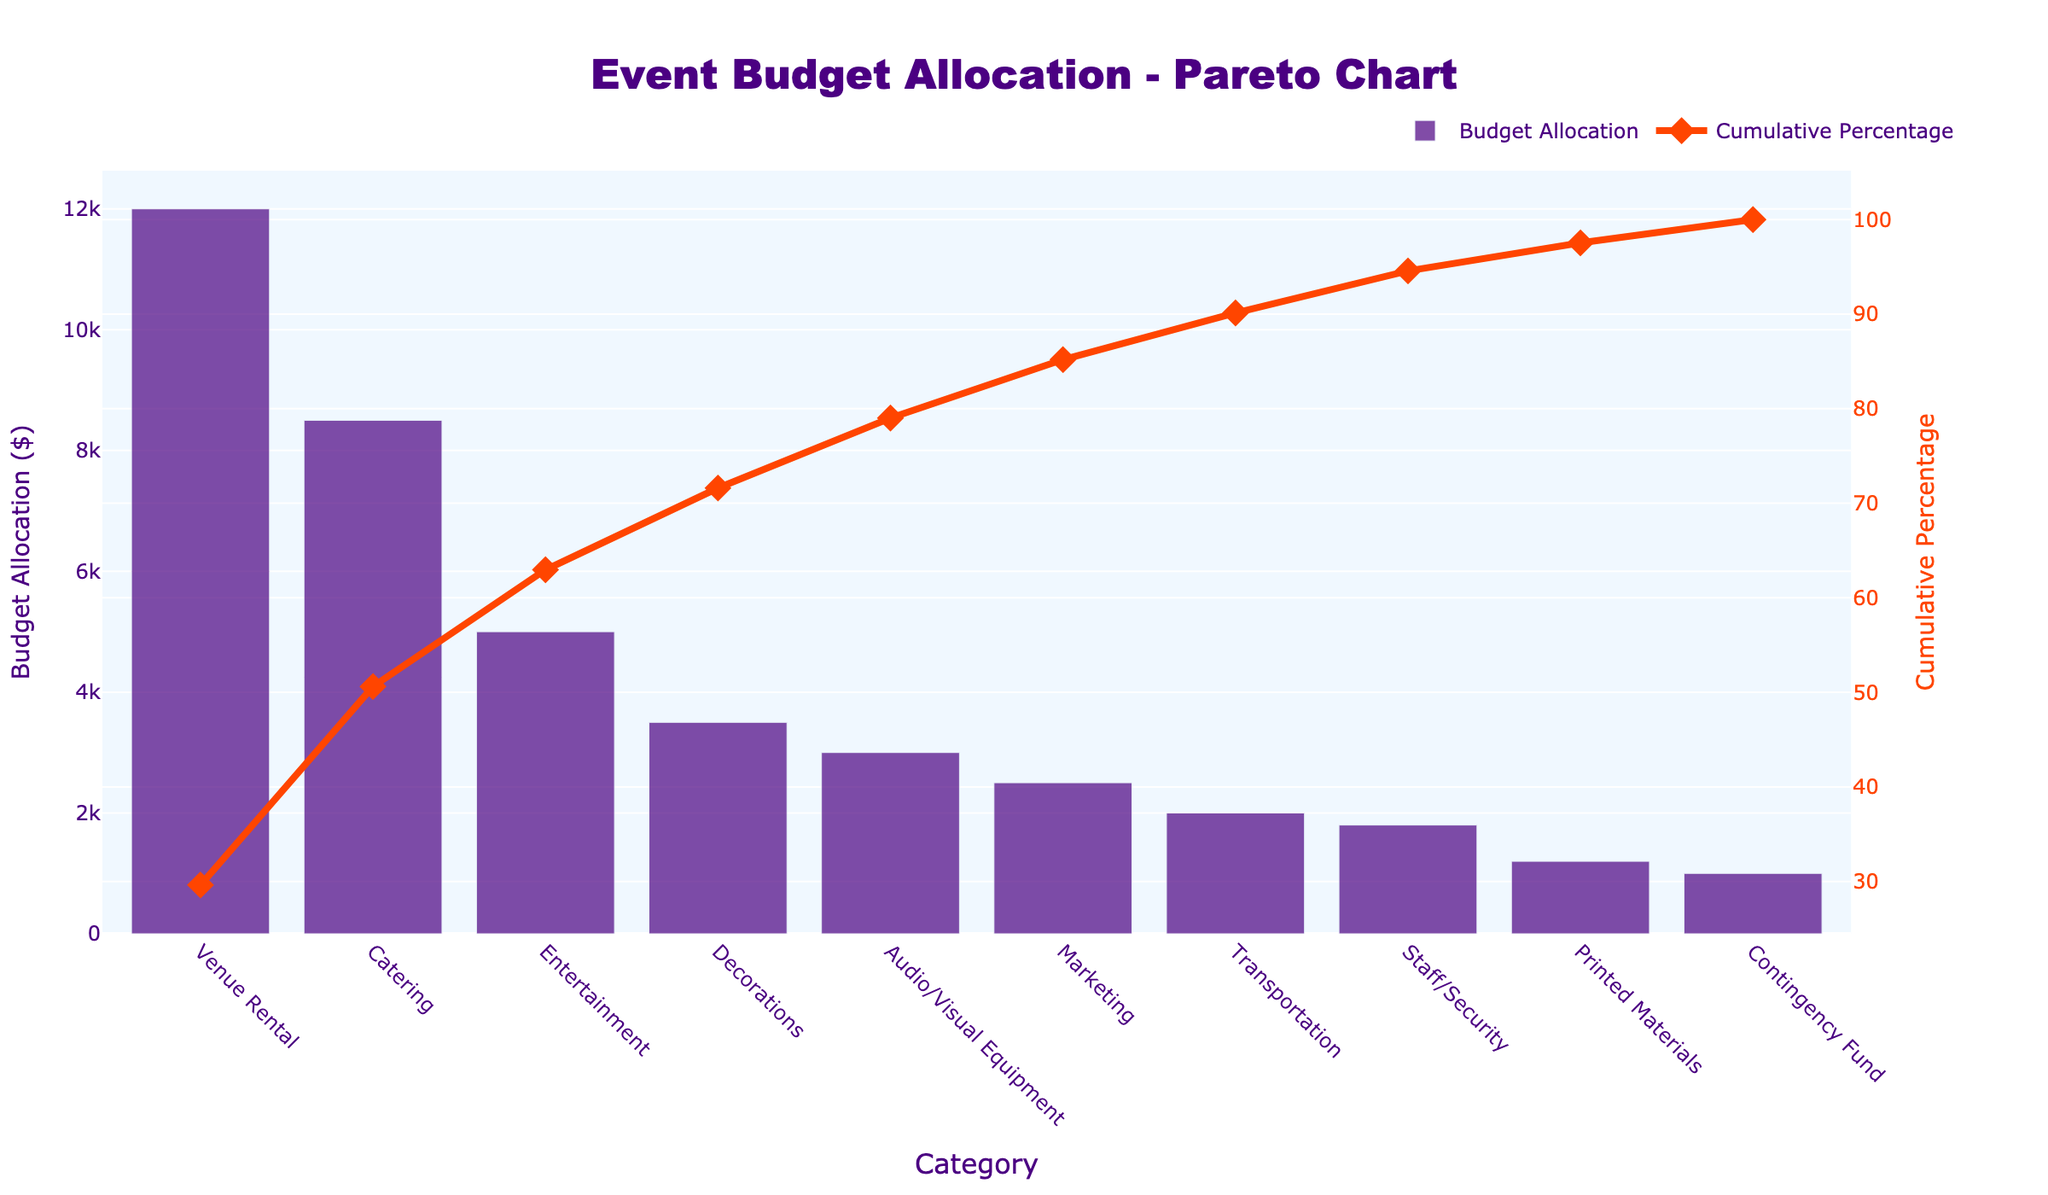What is the title of the Pareto chart? The title of the chart is prominently displayed at the top and reads "Event Budget Allocation - Pareto Chart".
Answer: Event Budget Allocation - Pareto Chart What category has the highest budget allocation? The first bar on the x-axis is the tallest, indicating the "Venue Rental" category.
Answer: Venue Rental How much money is allocated to the "Catering" category? The height of the second bar on the chart represents the "Catering" category, which is labeled as $8,500.
Answer: $8,500 What percentage of the total budget is accounted for by the "Venue Rental" and "Catering" categories together? Summing the budget for "Venue Rental" ($12,000) and "Catering" ($8,500) gives $20,500. The cumulative percentage line for the "Catering" category is just above 55%, indicating these two categories combined account for around 57%.
Answer: 57% Which category contributes to reaching the 80% cumulative budget allocation? The cumulative percentage line crosses the 80% mark between "Audio/Visual Equipment" and "Marketing". So, "Audio/Visual Equipment" is the last category contributing to the 80% cumulative total.
Answer: Audio/Visual Equipment What is the cumulative percentage after the "Entertainment" category? The line graph corresponding to the cumulative percentage shows a value of approximately 72% at the "Entertainment" category.
Answer: 72% Does the "Contingency Fund" have a higher budget allocation than "Printed Materials"? The bar representing the "Contingency Fund" is shorter than the "Printed Materials" bar, indicating a lower budget allocation for the former.
Answer: No Between "Staff/Security" and "Transportation," which has a higher budget allocation? The bar representing "Transportation" is taller than the "Staff/Security" bar, indicating a higher budget allocation for "Transportation".
Answer: Transportation What are the colors used for the bar and line charts in the figure? The bars are colored in purple, while the line chart is shown in orange-red.
Answer: Purple and orange-red What is the difference in budget allocations between the highest and lowest categories? The highest category "Venue Rental" has a budget of $12,000, and the lowest category "Contingency Fund" has $1,000. Subtracting $1,000 from $12,000 gives a difference of $11,000.
Answer: $11,000 